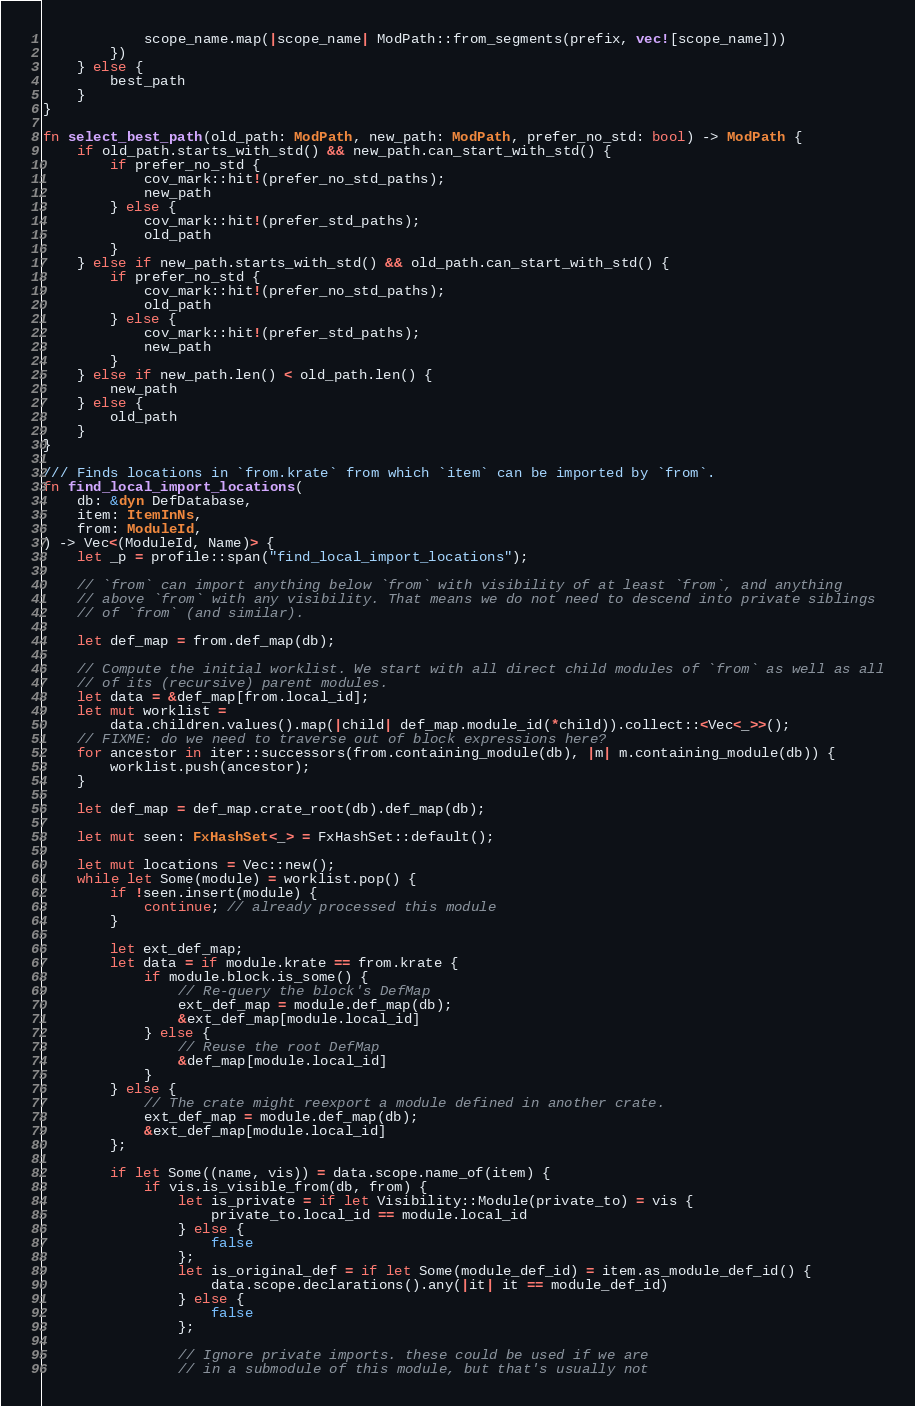Convert code to text. <code><loc_0><loc_0><loc_500><loc_500><_Rust_>            scope_name.map(|scope_name| ModPath::from_segments(prefix, vec![scope_name]))
        })
    } else {
        best_path
    }
}

fn select_best_path(old_path: ModPath, new_path: ModPath, prefer_no_std: bool) -> ModPath {
    if old_path.starts_with_std() && new_path.can_start_with_std() {
        if prefer_no_std {
            cov_mark::hit!(prefer_no_std_paths);
            new_path
        } else {
            cov_mark::hit!(prefer_std_paths);
            old_path
        }
    } else if new_path.starts_with_std() && old_path.can_start_with_std() {
        if prefer_no_std {
            cov_mark::hit!(prefer_no_std_paths);
            old_path
        } else {
            cov_mark::hit!(prefer_std_paths);
            new_path
        }
    } else if new_path.len() < old_path.len() {
        new_path
    } else {
        old_path
    }
}

/// Finds locations in `from.krate` from which `item` can be imported by `from`.
fn find_local_import_locations(
    db: &dyn DefDatabase,
    item: ItemInNs,
    from: ModuleId,
) -> Vec<(ModuleId, Name)> {
    let _p = profile::span("find_local_import_locations");

    // `from` can import anything below `from` with visibility of at least `from`, and anything
    // above `from` with any visibility. That means we do not need to descend into private siblings
    // of `from` (and similar).

    let def_map = from.def_map(db);

    // Compute the initial worklist. We start with all direct child modules of `from` as well as all
    // of its (recursive) parent modules.
    let data = &def_map[from.local_id];
    let mut worklist =
        data.children.values().map(|child| def_map.module_id(*child)).collect::<Vec<_>>();
    // FIXME: do we need to traverse out of block expressions here?
    for ancestor in iter::successors(from.containing_module(db), |m| m.containing_module(db)) {
        worklist.push(ancestor);
    }

    let def_map = def_map.crate_root(db).def_map(db);

    let mut seen: FxHashSet<_> = FxHashSet::default();

    let mut locations = Vec::new();
    while let Some(module) = worklist.pop() {
        if !seen.insert(module) {
            continue; // already processed this module
        }

        let ext_def_map;
        let data = if module.krate == from.krate {
            if module.block.is_some() {
                // Re-query the block's DefMap
                ext_def_map = module.def_map(db);
                &ext_def_map[module.local_id]
            } else {
                // Reuse the root DefMap
                &def_map[module.local_id]
            }
        } else {
            // The crate might reexport a module defined in another crate.
            ext_def_map = module.def_map(db);
            &ext_def_map[module.local_id]
        };

        if let Some((name, vis)) = data.scope.name_of(item) {
            if vis.is_visible_from(db, from) {
                let is_private = if let Visibility::Module(private_to) = vis {
                    private_to.local_id == module.local_id
                } else {
                    false
                };
                let is_original_def = if let Some(module_def_id) = item.as_module_def_id() {
                    data.scope.declarations().any(|it| it == module_def_id)
                } else {
                    false
                };

                // Ignore private imports. these could be used if we are
                // in a submodule of this module, but that's usually not</code> 